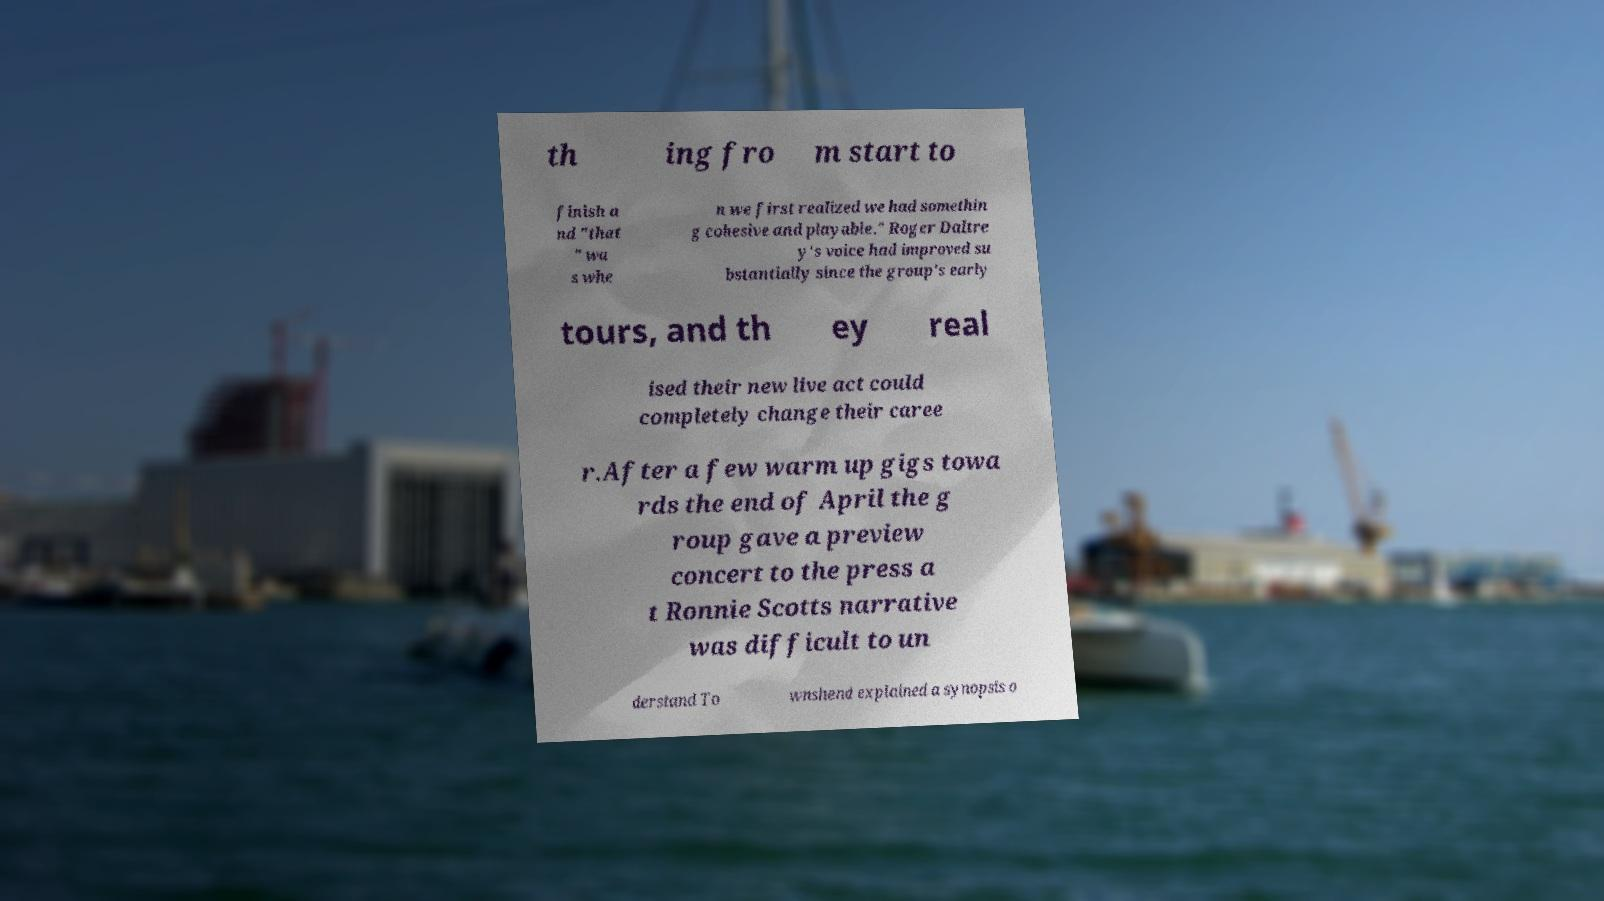Could you extract and type out the text from this image? th ing fro m start to finish a nd "that " wa s whe n we first realized we had somethin g cohesive and playable." Roger Daltre y's voice had improved su bstantially since the group's early tours, and th ey real ised their new live act could completely change their caree r.After a few warm up gigs towa rds the end of April the g roup gave a preview concert to the press a t Ronnie Scotts narrative was difficult to un derstand To wnshend explained a synopsis o 